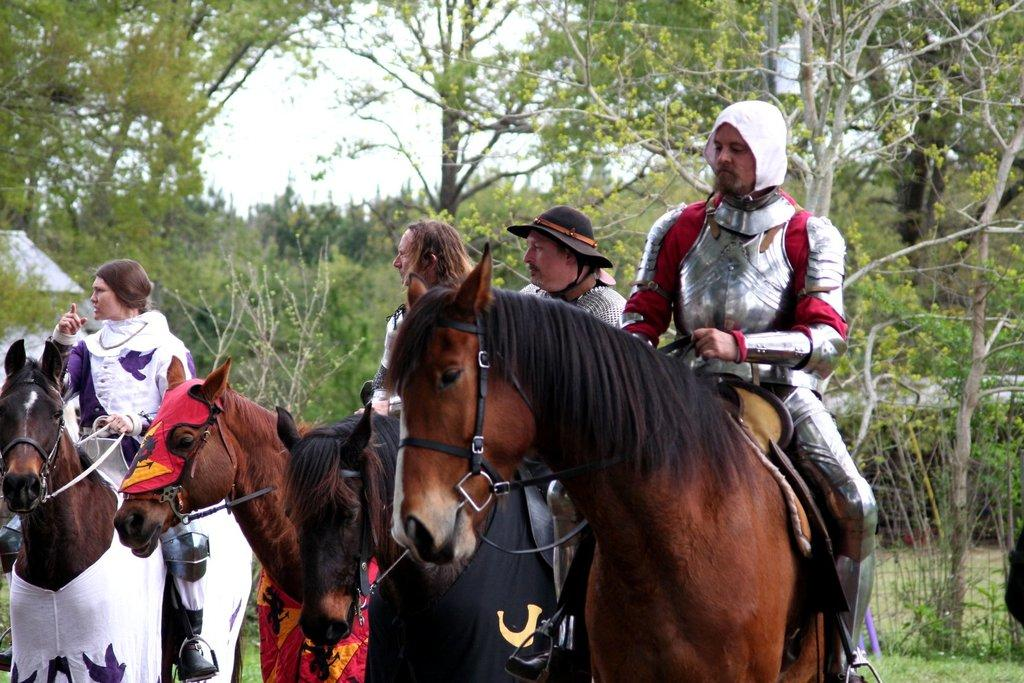How many people are in the image? There are four people in the image. What are the people doing in the image? The people are sitting on horses. What can be seen in the background of the image? There are trees and the sky visible in the background of the image. What type of scent can be detected from the horses in the image? There is no mention of a scent in the image, so it cannot be determined from the image. 